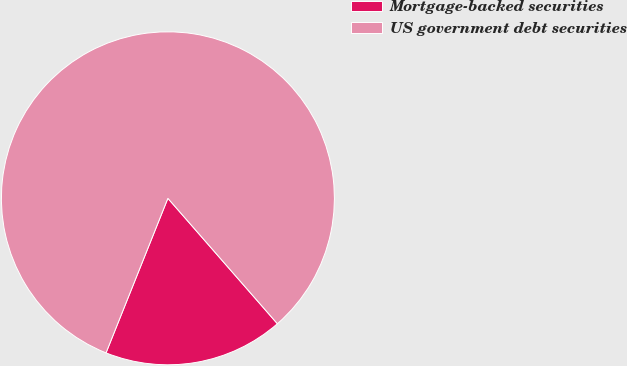<chart> <loc_0><loc_0><loc_500><loc_500><pie_chart><fcel>Mortgage-backed securities<fcel>US government debt securities<nl><fcel>17.48%<fcel>82.52%<nl></chart> 